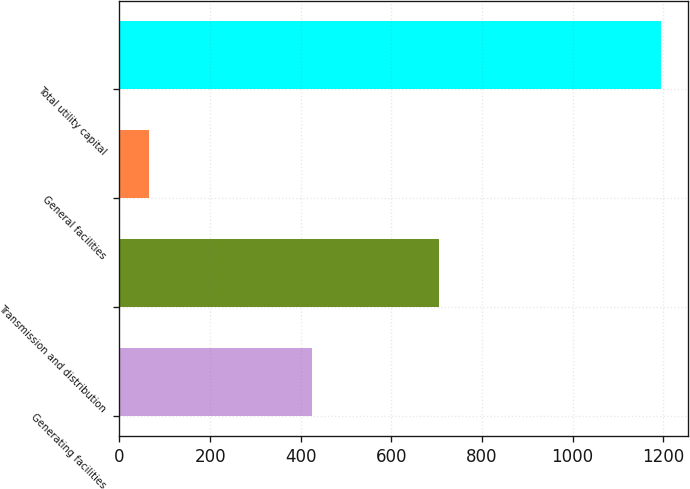Convert chart. <chart><loc_0><loc_0><loc_500><loc_500><bar_chart><fcel>Generating facilities<fcel>Transmission and distribution<fcel>General facilities<fcel>Total utility capital<nl><fcel>425<fcel>705<fcel>66<fcel>1196<nl></chart> 